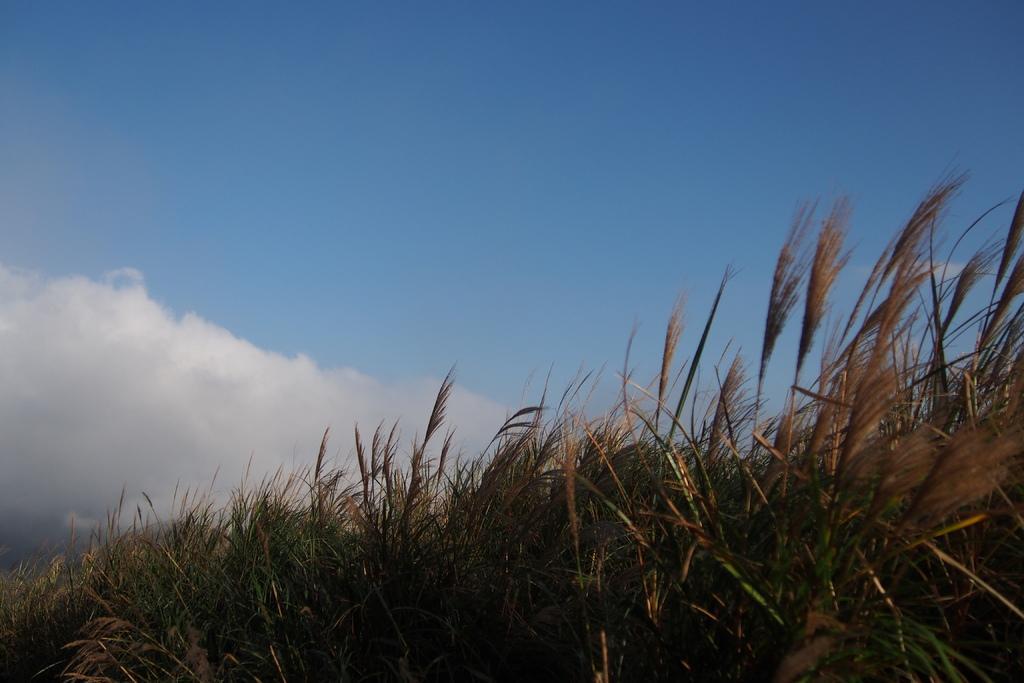Describe this image in one or two sentences. At the foreground of the image we can see some plants and at the background of the image there is clear sky. 